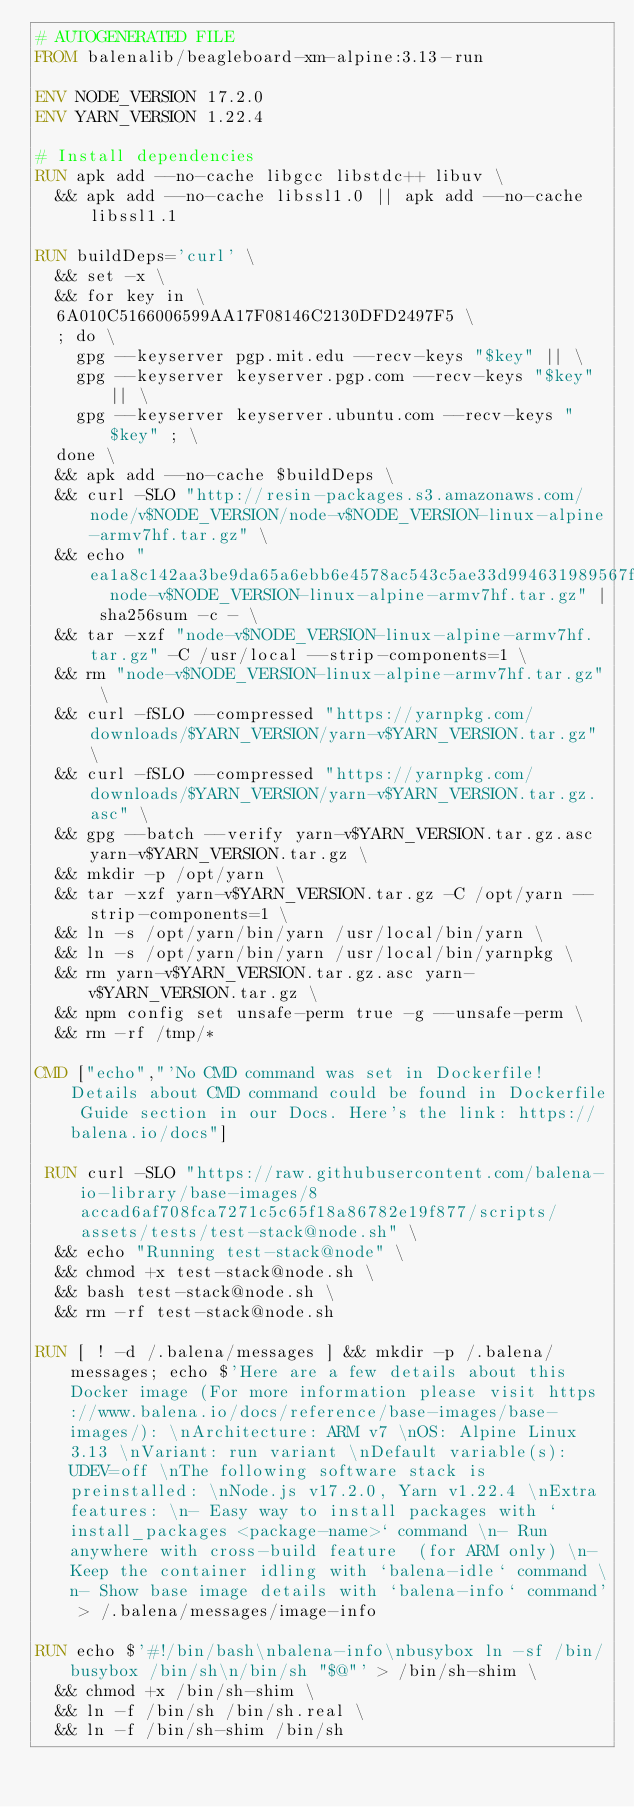Convert code to text. <code><loc_0><loc_0><loc_500><loc_500><_Dockerfile_># AUTOGENERATED FILE
FROM balenalib/beagleboard-xm-alpine:3.13-run

ENV NODE_VERSION 17.2.0
ENV YARN_VERSION 1.22.4

# Install dependencies
RUN apk add --no-cache libgcc libstdc++ libuv \
	&& apk add --no-cache libssl1.0 || apk add --no-cache libssl1.1

RUN buildDeps='curl' \
	&& set -x \
	&& for key in \
	6A010C5166006599AA17F08146C2130DFD2497F5 \
	; do \
		gpg --keyserver pgp.mit.edu --recv-keys "$key" || \
		gpg --keyserver keyserver.pgp.com --recv-keys "$key" || \
		gpg --keyserver keyserver.ubuntu.com --recv-keys "$key" ; \
	done \
	&& apk add --no-cache $buildDeps \
	&& curl -SLO "http://resin-packages.s3.amazonaws.com/node/v$NODE_VERSION/node-v$NODE_VERSION-linux-alpine-armv7hf.tar.gz" \
	&& echo "ea1a8c142aa3be9da65a6ebb6e4578ac543c5ae33d994631989567fad49a344a  node-v$NODE_VERSION-linux-alpine-armv7hf.tar.gz" | sha256sum -c - \
	&& tar -xzf "node-v$NODE_VERSION-linux-alpine-armv7hf.tar.gz" -C /usr/local --strip-components=1 \
	&& rm "node-v$NODE_VERSION-linux-alpine-armv7hf.tar.gz" \
	&& curl -fSLO --compressed "https://yarnpkg.com/downloads/$YARN_VERSION/yarn-v$YARN_VERSION.tar.gz" \
	&& curl -fSLO --compressed "https://yarnpkg.com/downloads/$YARN_VERSION/yarn-v$YARN_VERSION.tar.gz.asc" \
	&& gpg --batch --verify yarn-v$YARN_VERSION.tar.gz.asc yarn-v$YARN_VERSION.tar.gz \
	&& mkdir -p /opt/yarn \
	&& tar -xzf yarn-v$YARN_VERSION.tar.gz -C /opt/yarn --strip-components=1 \
	&& ln -s /opt/yarn/bin/yarn /usr/local/bin/yarn \
	&& ln -s /opt/yarn/bin/yarn /usr/local/bin/yarnpkg \
	&& rm yarn-v$YARN_VERSION.tar.gz.asc yarn-v$YARN_VERSION.tar.gz \
	&& npm config set unsafe-perm true -g --unsafe-perm \
	&& rm -rf /tmp/*

CMD ["echo","'No CMD command was set in Dockerfile! Details about CMD command could be found in Dockerfile Guide section in our Docs. Here's the link: https://balena.io/docs"]

 RUN curl -SLO "https://raw.githubusercontent.com/balena-io-library/base-images/8accad6af708fca7271c5c65f18a86782e19f877/scripts/assets/tests/test-stack@node.sh" \
  && echo "Running test-stack@node" \
  && chmod +x test-stack@node.sh \
  && bash test-stack@node.sh \
  && rm -rf test-stack@node.sh 

RUN [ ! -d /.balena/messages ] && mkdir -p /.balena/messages; echo $'Here are a few details about this Docker image (For more information please visit https://www.balena.io/docs/reference/base-images/base-images/): \nArchitecture: ARM v7 \nOS: Alpine Linux 3.13 \nVariant: run variant \nDefault variable(s): UDEV=off \nThe following software stack is preinstalled: \nNode.js v17.2.0, Yarn v1.22.4 \nExtra features: \n- Easy way to install packages with `install_packages <package-name>` command \n- Run anywhere with cross-build feature  (for ARM only) \n- Keep the container idling with `balena-idle` command \n- Show base image details with `balena-info` command' > /.balena/messages/image-info

RUN echo $'#!/bin/bash\nbalena-info\nbusybox ln -sf /bin/busybox /bin/sh\n/bin/sh "$@"' > /bin/sh-shim \
	&& chmod +x /bin/sh-shim \
	&& ln -f /bin/sh /bin/sh.real \
	&& ln -f /bin/sh-shim /bin/sh</code> 